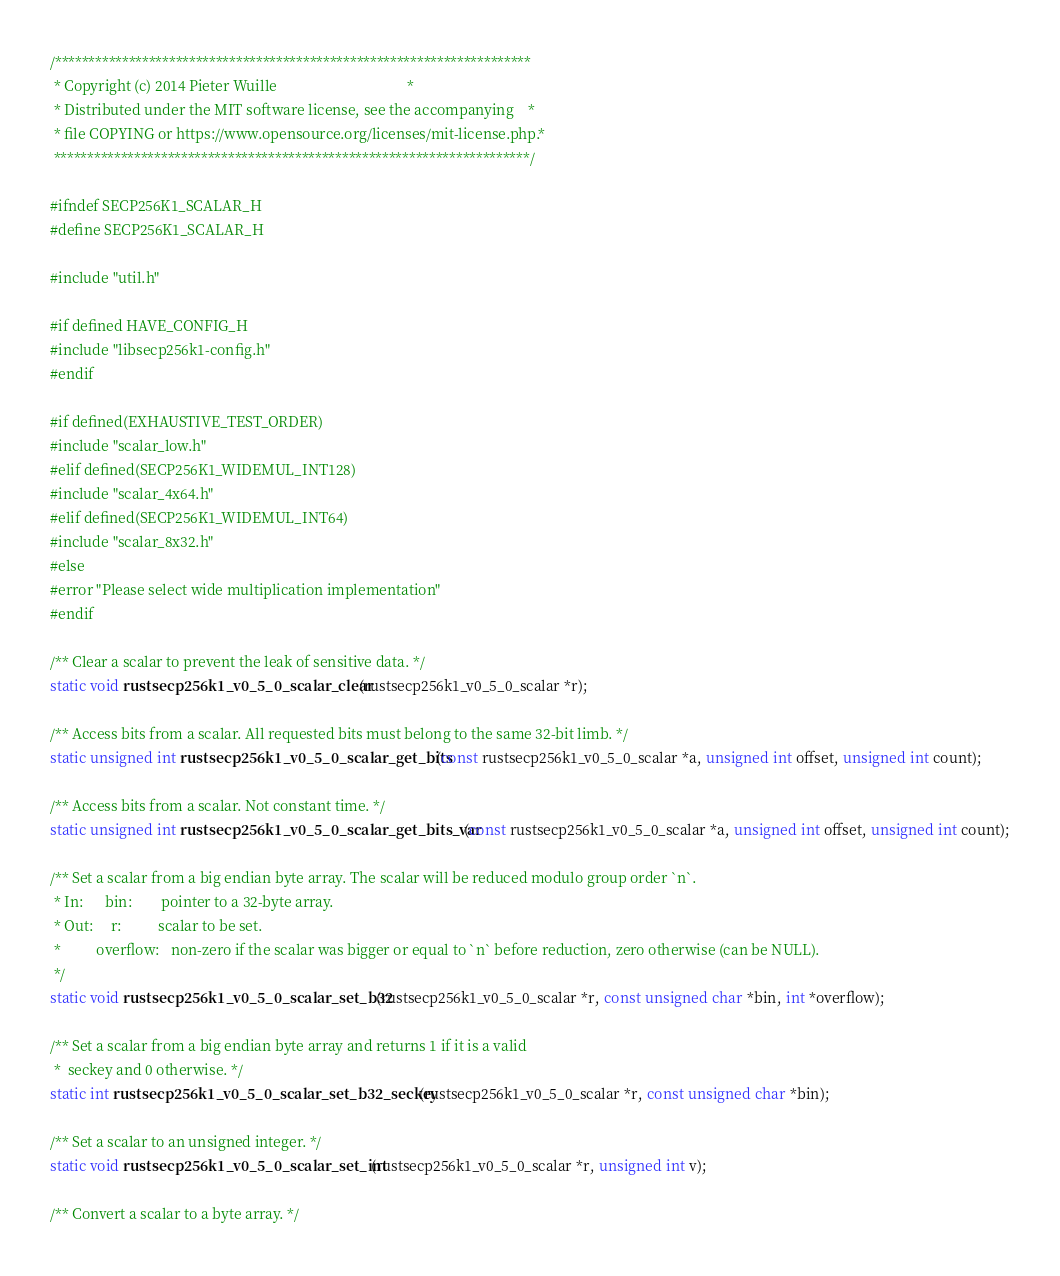<code> <loc_0><loc_0><loc_500><loc_500><_C_>/***********************************************************************
 * Copyright (c) 2014 Pieter Wuille                                    *
 * Distributed under the MIT software license, see the accompanying    *
 * file COPYING or https://www.opensource.org/licenses/mit-license.php.*
 ***********************************************************************/

#ifndef SECP256K1_SCALAR_H
#define SECP256K1_SCALAR_H

#include "util.h"

#if defined HAVE_CONFIG_H
#include "libsecp256k1-config.h"
#endif

#if defined(EXHAUSTIVE_TEST_ORDER)
#include "scalar_low.h"
#elif defined(SECP256K1_WIDEMUL_INT128)
#include "scalar_4x64.h"
#elif defined(SECP256K1_WIDEMUL_INT64)
#include "scalar_8x32.h"
#else
#error "Please select wide multiplication implementation"
#endif

/** Clear a scalar to prevent the leak of sensitive data. */
static void rustsecp256k1_v0_5_0_scalar_clear(rustsecp256k1_v0_5_0_scalar *r);

/** Access bits from a scalar. All requested bits must belong to the same 32-bit limb. */
static unsigned int rustsecp256k1_v0_5_0_scalar_get_bits(const rustsecp256k1_v0_5_0_scalar *a, unsigned int offset, unsigned int count);

/** Access bits from a scalar. Not constant time. */
static unsigned int rustsecp256k1_v0_5_0_scalar_get_bits_var(const rustsecp256k1_v0_5_0_scalar *a, unsigned int offset, unsigned int count);

/** Set a scalar from a big endian byte array. The scalar will be reduced modulo group order `n`.
 * In:      bin:        pointer to a 32-byte array.
 * Out:     r:          scalar to be set.
 *          overflow:   non-zero if the scalar was bigger or equal to `n` before reduction, zero otherwise (can be NULL).
 */
static void rustsecp256k1_v0_5_0_scalar_set_b32(rustsecp256k1_v0_5_0_scalar *r, const unsigned char *bin, int *overflow);

/** Set a scalar from a big endian byte array and returns 1 if it is a valid
 *  seckey and 0 otherwise. */
static int rustsecp256k1_v0_5_0_scalar_set_b32_seckey(rustsecp256k1_v0_5_0_scalar *r, const unsigned char *bin);

/** Set a scalar to an unsigned integer. */
static void rustsecp256k1_v0_5_0_scalar_set_int(rustsecp256k1_v0_5_0_scalar *r, unsigned int v);

/** Convert a scalar to a byte array. */</code> 